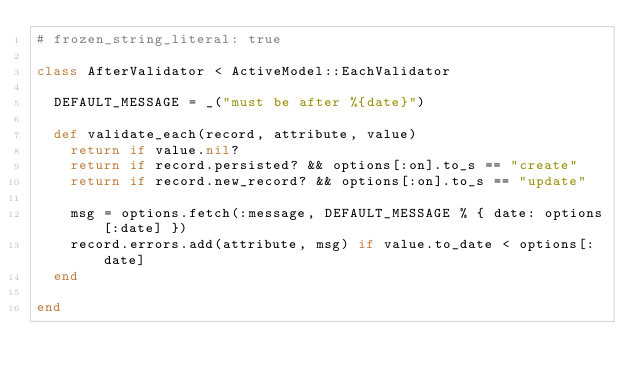Convert code to text. <code><loc_0><loc_0><loc_500><loc_500><_Ruby_># frozen_string_literal: true

class AfterValidator < ActiveModel::EachValidator

  DEFAULT_MESSAGE = _("must be after %{date}")

  def validate_each(record, attribute, value)
    return if value.nil?
    return if record.persisted? && options[:on].to_s == "create"
    return if record.new_record? && options[:on].to_s == "update"

    msg = options.fetch(:message, DEFAULT_MESSAGE % { date: options[:date] })
    record.errors.add(attribute, msg) if value.to_date < options[:date]
  end

end
</code> 